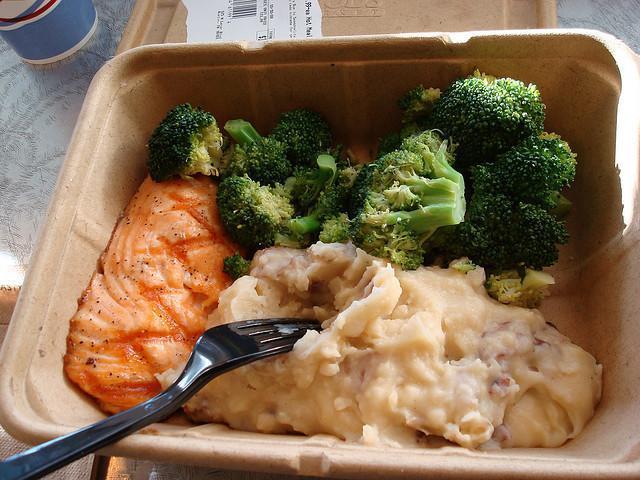How many forks are there?
Give a very brief answer. 1. How many zebras have their head up?
Give a very brief answer. 0. 